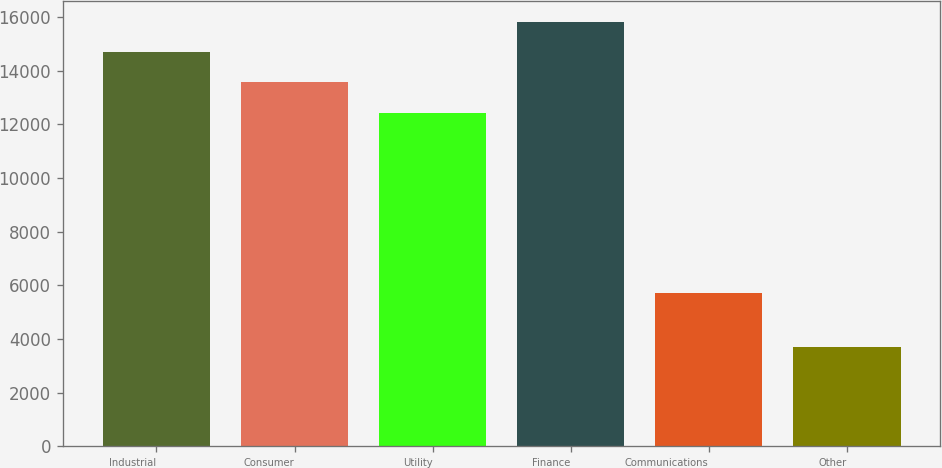Convert chart. <chart><loc_0><loc_0><loc_500><loc_500><bar_chart><fcel>Industrial<fcel>Consumer<fcel>Utility<fcel>Finance<fcel>Communications<fcel>Other<nl><fcel>14690.6<fcel>13562.3<fcel>12434<fcel>15818.9<fcel>5714<fcel>3713<nl></chart> 